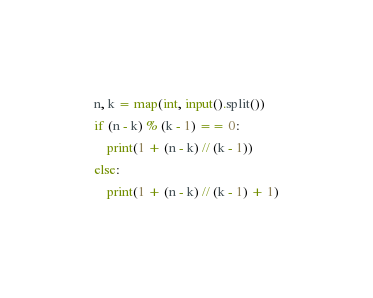<code> <loc_0><loc_0><loc_500><loc_500><_Python_>n, k = map(int, input().split())
if (n - k) % (k - 1) == 0:
    print(1 + (n - k) // (k - 1))
else:
    print(1 + (n - k) // (k - 1) + 1)
</code> 